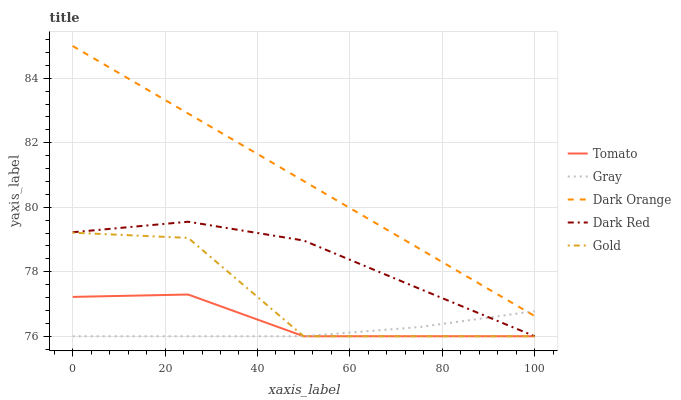Does Dark Red have the minimum area under the curve?
Answer yes or no. No. Does Dark Red have the maximum area under the curve?
Answer yes or no. No. Is Gray the smoothest?
Answer yes or no. No. Is Gray the roughest?
Answer yes or no. No. Does Dark Orange have the lowest value?
Answer yes or no. No. Does Dark Red have the highest value?
Answer yes or no. No. Is Dark Red less than Dark Orange?
Answer yes or no. Yes. Is Dark Orange greater than Gold?
Answer yes or no. Yes. Does Dark Red intersect Dark Orange?
Answer yes or no. No. 